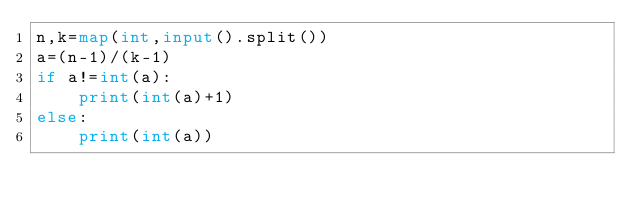Convert code to text. <code><loc_0><loc_0><loc_500><loc_500><_Python_>n,k=map(int,input().split())
a=(n-1)/(k-1)
if a!=int(a):
    print(int(a)+1)
else:
    print(int(a))</code> 